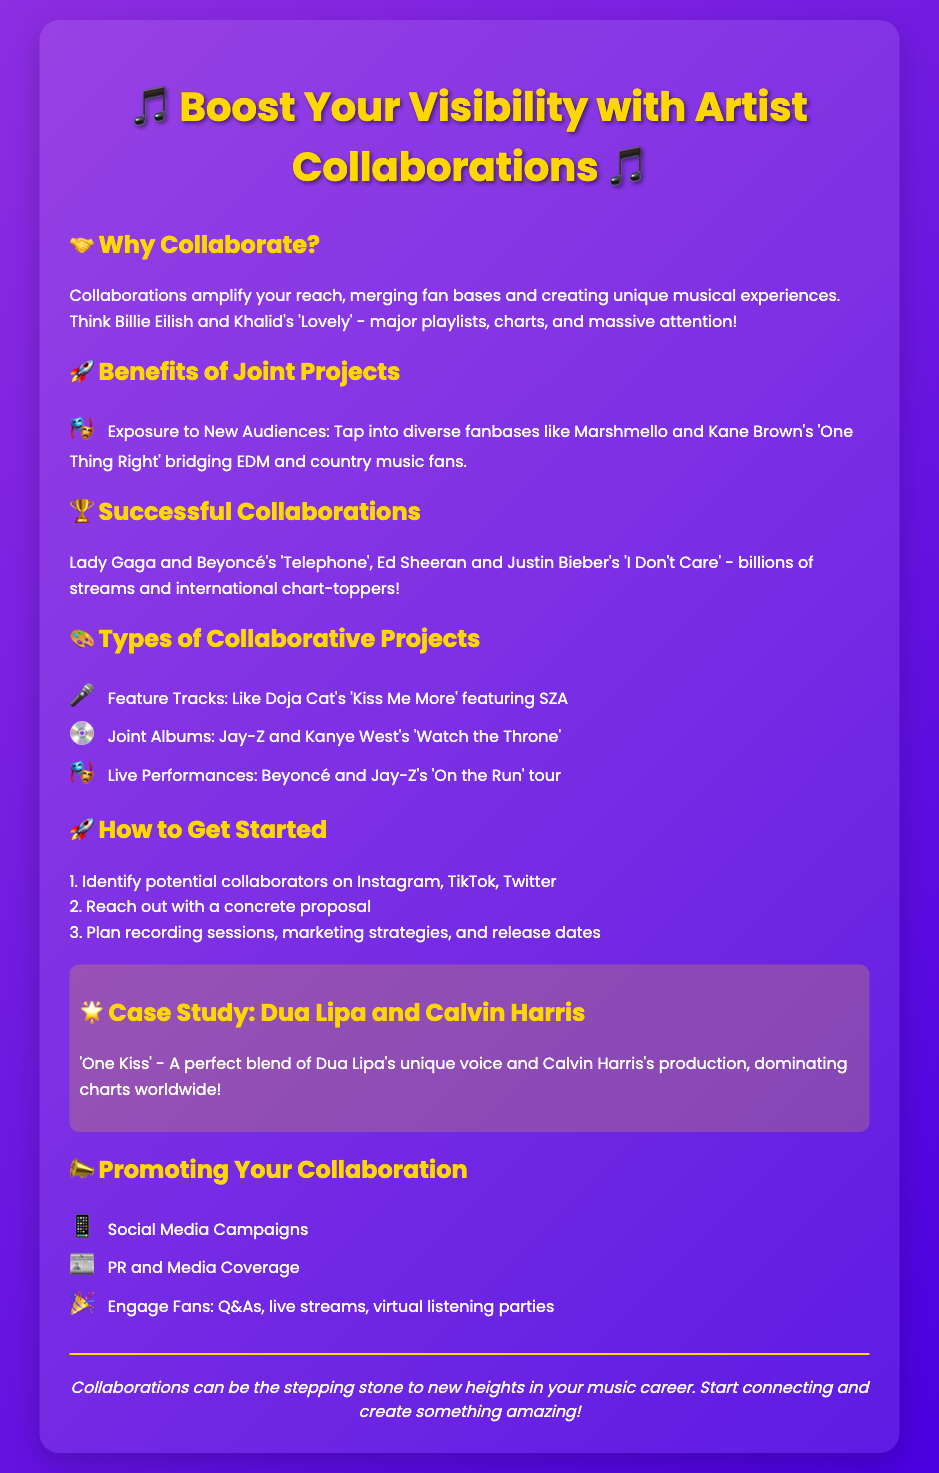What are the names of two artists mentioned in a successful collaboration? The document lists Lady Gaga and Beyoncé as part of a successful collaboration example.
Answer: Lady Gaga and Beyoncé What is a benefit of joint projects? The document states that joint projects provide exposure to new audiences by merging diverse fanbases.
Answer: Exposure to New Audiences What type of project is "Kiss Me More"? According to the document, "Kiss Me More" is categorized as a feature track.
Answer: Feature Track Who collaborated on the joint album "Watch the Throne"? The document specifies that Jay-Z and Kanye West collaborated on this album.
Answer: Jay-Z and Kanye West What should be identified first when getting started with collaborations? The document advises to identify potential collaborators as the first step.
Answer: Identify potential collaborators What is an example of promoting your collaboration? The document lists social media campaigns as one method of promotion.
Answer: Social Media Campaigns What song exemplifies a case study in the document? The document mentions "One Kiss" as a perfect blend in the case study.
Answer: One Kiss What is the role of social media in collaborations according to the flyer? The document indicates that social media is important for campaigns related to the collaborations.
Answer: Social Media Campaigns How many steps are listed for getting started with collaborations? The document outlines three steps for starting collaborations.
Answer: Three steps 